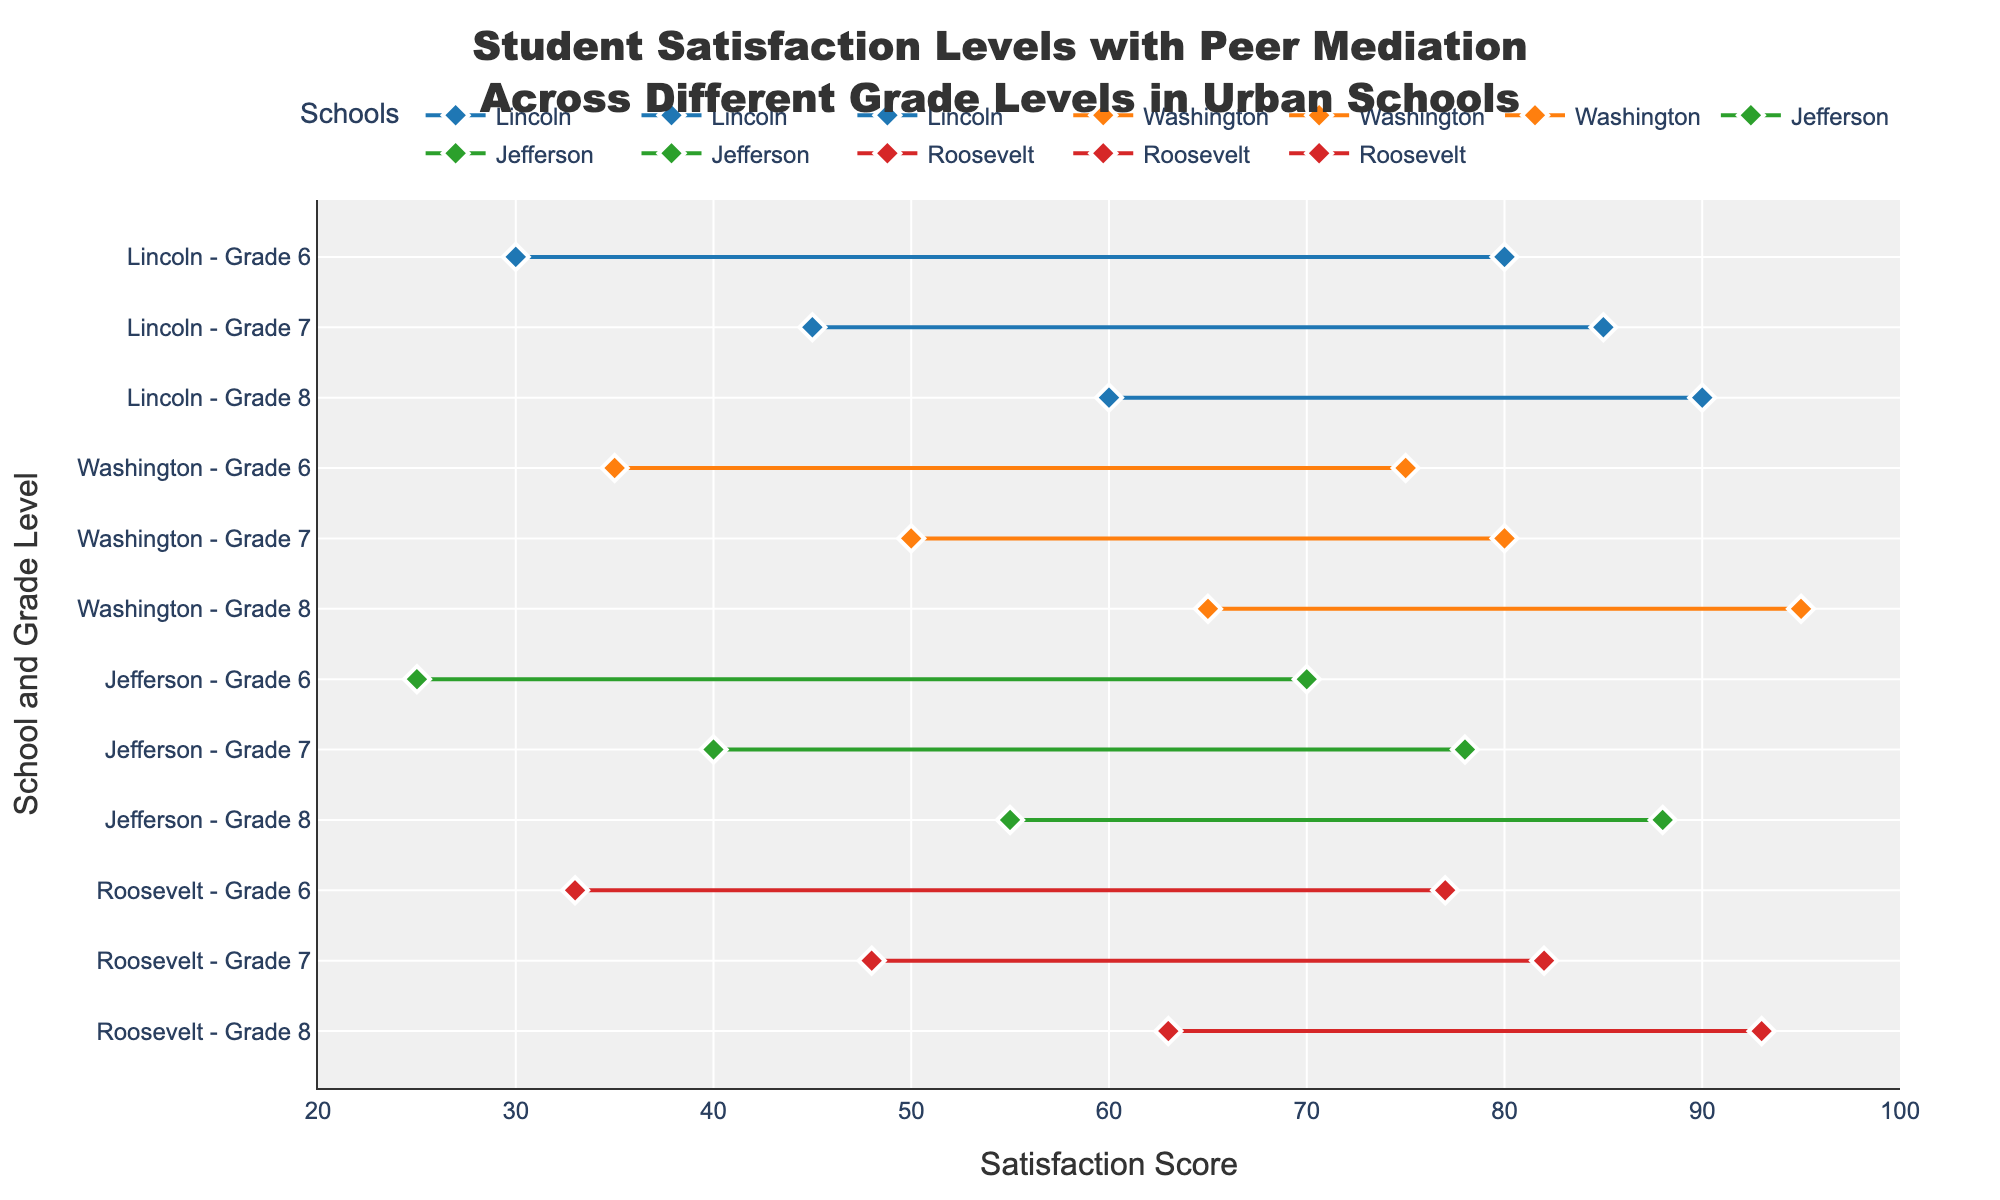What is the satisfaction score range for 6th grade at Lincoln Middle School? The plot shows the satisfaction score range as the horizontal line with the markers at the ends. The range for 6th grade at Lincoln Middle School starts at 30 and ends at 80.
Answer: 30-80 Which school has the highest maximum satisfaction score for 8th grade? We compare the maximum satisfaction scores for 8th grade across all the schools. Lincoln Middle School has a maximum score of 90, Washington Middle School has 95, Jefferson Middle School has 88, and Roosevelt Middle School has 93. The highest is 95 at Washington Middle School.
Answer: Washington Middle School What is the average minimum satisfaction score for all schools in grade 7? To find the average minimum satisfaction score for grade 7, add the minimum scores and divide by the number of schools. The minimum scores are: Lincoln - 45, Washington - 50, Jefferson - 40, and Roosevelt - 48. Their sum is 45 + 50 + 40 + 48 = 183. Divide 183 by 4 (the number of schools) to get 183/4 = 45.75.
Answer: 45.75 How does the satisfaction score range change from 6th to 8th grade at Jefferson Middle School? Track the min and max scores from 6th to 8th grade at Jefferson Middle School. For 6th grade, the range is 25-70, for 7th grade it’s 40-78, and for 8th grade it’s 55-88. As grade level increases, both minimum and maximum scores increase.
Answer: Both minimum and maximum scores increase Which grade level at Roosevelt Middle School has the smallest range in satisfaction scores? Calculate the range for each grade by subtracting the minimum score from the maximum score. For 6th grade: 77 - 33 = 44. For 7th grade: 82 - 48 = 34. For 8th grade: 93 - 63 = 30. The smallest range is in 8th grade with a score range of 30.
Answer: 8th grade Among the 6th grades across all schools, which school has the narrowest range of satisfaction scores? The range is calculated by subtracting the minimum score from the maximum score for each 6th grade in the schools: Lincoln (80-30 = 50), Washington (75-35 = 40), Jefferson (70-25 = 45), Roosevelt (77-33 = 44). The narrowest range is 40 at Washington.
Answer: Washington Middle School What is the difference between the highest and lowest maximum satisfaction scores among all schools for 7th grade? Identify the maximum satisfaction scores for 7th grade: Lincoln (85), Washington (80), Jefferson (78), Roosevelt (82). The highest is 85 (Lincoln) and the lowest is 78 (Jefferson). The difference is 85 - 78 = 7.
Answer: 7 For which school does the range in satisfaction scores increase the most from 6th to 8th grade? Calculate the change in range by subtracting the range of 6th grade from the range of 8th grade for each school. Lincoln: (90-60) - (80-30) = 30 - 50 = -20. Washington: (95-65) - (75-35) = 30 - 40 = -10. Jefferson: (88-55) - (70-25) = 33 - 45 = -12. Roosevelt: (93-63) - (77-33) = 30 - 44 = -14. None increase; all are negative, indicating a decrease.
Answer: None 